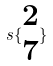<formula> <loc_0><loc_0><loc_500><loc_500>s \{ \begin{matrix} 2 \\ 7 \end{matrix} \}</formula> 